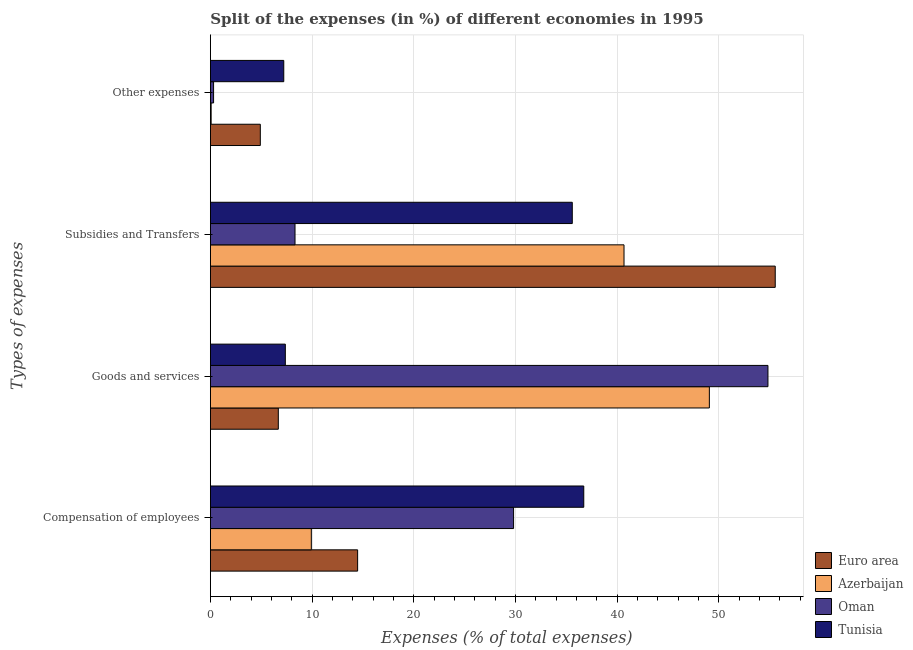How many groups of bars are there?
Your answer should be compact. 4. Are the number of bars per tick equal to the number of legend labels?
Offer a very short reply. Yes. What is the label of the 2nd group of bars from the top?
Keep it short and to the point. Subsidies and Transfers. What is the percentage of amount spent on compensation of employees in Oman?
Provide a short and direct response. 29.81. Across all countries, what is the maximum percentage of amount spent on subsidies?
Your response must be concise. 55.53. Across all countries, what is the minimum percentage of amount spent on goods and services?
Provide a short and direct response. 6.68. In which country was the percentage of amount spent on subsidies minimum?
Your answer should be very brief. Oman. What is the total percentage of amount spent on compensation of employees in the graph?
Provide a succinct answer. 90.92. What is the difference between the percentage of amount spent on goods and services in Azerbaijan and that in Oman?
Give a very brief answer. -5.76. What is the difference between the percentage of amount spent on compensation of employees in Azerbaijan and the percentage of amount spent on subsidies in Euro area?
Your response must be concise. -45.61. What is the average percentage of amount spent on subsidies per country?
Your answer should be very brief. 35.03. What is the difference between the percentage of amount spent on compensation of employees and percentage of amount spent on subsidies in Tunisia?
Your answer should be compact. 1.13. What is the ratio of the percentage of amount spent on goods and services in Euro area to that in Oman?
Offer a very short reply. 0.12. What is the difference between the highest and the second highest percentage of amount spent on subsidies?
Provide a short and direct response. 14.87. What is the difference between the highest and the lowest percentage of amount spent on other expenses?
Your answer should be compact. 7.14. Is the sum of the percentage of amount spent on goods and services in Euro area and Oman greater than the maximum percentage of amount spent on other expenses across all countries?
Your response must be concise. Yes. Is it the case that in every country, the sum of the percentage of amount spent on goods and services and percentage of amount spent on other expenses is greater than the sum of percentage of amount spent on subsidies and percentage of amount spent on compensation of employees?
Your response must be concise. No. What does the 4th bar from the top in Subsidies and Transfers represents?
Offer a terse response. Euro area. Is it the case that in every country, the sum of the percentage of amount spent on compensation of employees and percentage of amount spent on goods and services is greater than the percentage of amount spent on subsidies?
Offer a very short reply. No. Are all the bars in the graph horizontal?
Provide a short and direct response. Yes. What is the difference between two consecutive major ticks on the X-axis?
Provide a short and direct response. 10. Are the values on the major ticks of X-axis written in scientific E-notation?
Give a very brief answer. No. Does the graph contain any zero values?
Provide a succinct answer. No. What is the title of the graph?
Offer a terse response. Split of the expenses (in %) of different economies in 1995. Does "New Zealand" appear as one of the legend labels in the graph?
Give a very brief answer. No. What is the label or title of the X-axis?
Provide a short and direct response. Expenses (% of total expenses). What is the label or title of the Y-axis?
Your response must be concise. Types of expenses. What is the Expenses (% of total expenses) in Euro area in Compensation of employees?
Make the answer very short. 14.48. What is the Expenses (% of total expenses) in Azerbaijan in Compensation of employees?
Give a very brief answer. 9.92. What is the Expenses (% of total expenses) in Oman in Compensation of employees?
Your answer should be very brief. 29.81. What is the Expenses (% of total expenses) of Tunisia in Compensation of employees?
Keep it short and to the point. 36.71. What is the Expenses (% of total expenses) of Euro area in Goods and services?
Provide a succinct answer. 6.68. What is the Expenses (% of total expenses) in Azerbaijan in Goods and services?
Provide a short and direct response. 49.06. What is the Expenses (% of total expenses) in Oman in Goods and services?
Your answer should be very brief. 54.82. What is the Expenses (% of total expenses) in Tunisia in Goods and services?
Your response must be concise. 7.37. What is the Expenses (% of total expenses) in Euro area in Subsidies and Transfers?
Keep it short and to the point. 55.53. What is the Expenses (% of total expenses) of Azerbaijan in Subsidies and Transfers?
Ensure brevity in your answer.  40.67. What is the Expenses (% of total expenses) of Oman in Subsidies and Transfers?
Your response must be concise. 8.32. What is the Expenses (% of total expenses) in Tunisia in Subsidies and Transfers?
Provide a short and direct response. 35.58. What is the Expenses (% of total expenses) in Euro area in Other expenses?
Offer a terse response. 4.91. What is the Expenses (% of total expenses) in Azerbaijan in Other expenses?
Provide a succinct answer. 0.07. What is the Expenses (% of total expenses) in Oman in Other expenses?
Provide a short and direct response. 0.31. What is the Expenses (% of total expenses) in Tunisia in Other expenses?
Keep it short and to the point. 7.22. Across all Types of expenses, what is the maximum Expenses (% of total expenses) in Euro area?
Offer a very short reply. 55.53. Across all Types of expenses, what is the maximum Expenses (% of total expenses) of Azerbaijan?
Make the answer very short. 49.06. Across all Types of expenses, what is the maximum Expenses (% of total expenses) of Oman?
Ensure brevity in your answer.  54.82. Across all Types of expenses, what is the maximum Expenses (% of total expenses) in Tunisia?
Your answer should be compact. 36.71. Across all Types of expenses, what is the minimum Expenses (% of total expenses) of Euro area?
Ensure brevity in your answer.  4.91. Across all Types of expenses, what is the minimum Expenses (% of total expenses) in Azerbaijan?
Provide a short and direct response. 0.07. Across all Types of expenses, what is the minimum Expenses (% of total expenses) of Oman?
Give a very brief answer. 0.31. Across all Types of expenses, what is the minimum Expenses (% of total expenses) in Tunisia?
Offer a very short reply. 7.22. What is the total Expenses (% of total expenses) of Euro area in the graph?
Your response must be concise. 81.6. What is the total Expenses (% of total expenses) of Azerbaijan in the graph?
Make the answer very short. 99.72. What is the total Expenses (% of total expenses) of Oman in the graph?
Provide a short and direct response. 93.26. What is the total Expenses (% of total expenses) in Tunisia in the graph?
Offer a terse response. 86.87. What is the difference between the Expenses (% of total expenses) in Euro area in Compensation of employees and that in Goods and services?
Provide a succinct answer. 7.8. What is the difference between the Expenses (% of total expenses) in Azerbaijan in Compensation of employees and that in Goods and services?
Provide a short and direct response. -39.13. What is the difference between the Expenses (% of total expenses) in Oman in Compensation of employees and that in Goods and services?
Offer a terse response. -25.01. What is the difference between the Expenses (% of total expenses) of Tunisia in Compensation of employees and that in Goods and services?
Keep it short and to the point. 29.34. What is the difference between the Expenses (% of total expenses) in Euro area in Compensation of employees and that in Subsidies and Transfers?
Give a very brief answer. -41.06. What is the difference between the Expenses (% of total expenses) of Azerbaijan in Compensation of employees and that in Subsidies and Transfers?
Offer a terse response. -30.74. What is the difference between the Expenses (% of total expenses) in Oman in Compensation of employees and that in Subsidies and Transfers?
Your response must be concise. 21.49. What is the difference between the Expenses (% of total expenses) of Tunisia in Compensation of employees and that in Subsidies and Transfers?
Ensure brevity in your answer.  1.13. What is the difference between the Expenses (% of total expenses) in Euro area in Compensation of employees and that in Other expenses?
Provide a succinct answer. 9.57. What is the difference between the Expenses (% of total expenses) of Azerbaijan in Compensation of employees and that in Other expenses?
Ensure brevity in your answer.  9.85. What is the difference between the Expenses (% of total expenses) of Oman in Compensation of employees and that in Other expenses?
Offer a terse response. 29.49. What is the difference between the Expenses (% of total expenses) in Tunisia in Compensation of employees and that in Other expenses?
Your answer should be very brief. 29.5. What is the difference between the Expenses (% of total expenses) of Euro area in Goods and services and that in Subsidies and Transfers?
Provide a succinct answer. -48.86. What is the difference between the Expenses (% of total expenses) of Azerbaijan in Goods and services and that in Subsidies and Transfers?
Provide a succinct answer. 8.39. What is the difference between the Expenses (% of total expenses) in Oman in Goods and services and that in Subsidies and Transfers?
Your answer should be very brief. 46.5. What is the difference between the Expenses (% of total expenses) in Tunisia in Goods and services and that in Subsidies and Transfers?
Your response must be concise. -28.21. What is the difference between the Expenses (% of total expenses) in Euro area in Goods and services and that in Other expenses?
Offer a terse response. 1.77. What is the difference between the Expenses (% of total expenses) in Azerbaijan in Goods and services and that in Other expenses?
Provide a short and direct response. 48.98. What is the difference between the Expenses (% of total expenses) in Oman in Goods and services and that in Other expenses?
Ensure brevity in your answer.  54.5. What is the difference between the Expenses (% of total expenses) of Tunisia in Goods and services and that in Other expenses?
Your answer should be very brief. 0.15. What is the difference between the Expenses (% of total expenses) of Euro area in Subsidies and Transfers and that in Other expenses?
Ensure brevity in your answer.  50.63. What is the difference between the Expenses (% of total expenses) of Azerbaijan in Subsidies and Transfers and that in Other expenses?
Your answer should be very brief. 40.59. What is the difference between the Expenses (% of total expenses) of Oman in Subsidies and Transfers and that in Other expenses?
Offer a terse response. 8.01. What is the difference between the Expenses (% of total expenses) in Tunisia in Subsidies and Transfers and that in Other expenses?
Your answer should be compact. 28.36. What is the difference between the Expenses (% of total expenses) of Euro area in Compensation of employees and the Expenses (% of total expenses) of Azerbaijan in Goods and services?
Your answer should be very brief. -34.58. What is the difference between the Expenses (% of total expenses) of Euro area in Compensation of employees and the Expenses (% of total expenses) of Oman in Goods and services?
Keep it short and to the point. -40.34. What is the difference between the Expenses (% of total expenses) in Euro area in Compensation of employees and the Expenses (% of total expenses) in Tunisia in Goods and services?
Your response must be concise. 7.11. What is the difference between the Expenses (% of total expenses) of Azerbaijan in Compensation of employees and the Expenses (% of total expenses) of Oman in Goods and services?
Give a very brief answer. -44.89. What is the difference between the Expenses (% of total expenses) in Azerbaijan in Compensation of employees and the Expenses (% of total expenses) in Tunisia in Goods and services?
Ensure brevity in your answer.  2.56. What is the difference between the Expenses (% of total expenses) in Oman in Compensation of employees and the Expenses (% of total expenses) in Tunisia in Goods and services?
Keep it short and to the point. 22.44. What is the difference between the Expenses (% of total expenses) in Euro area in Compensation of employees and the Expenses (% of total expenses) in Azerbaijan in Subsidies and Transfers?
Keep it short and to the point. -26.19. What is the difference between the Expenses (% of total expenses) in Euro area in Compensation of employees and the Expenses (% of total expenses) in Oman in Subsidies and Transfers?
Your answer should be very brief. 6.15. What is the difference between the Expenses (% of total expenses) in Euro area in Compensation of employees and the Expenses (% of total expenses) in Tunisia in Subsidies and Transfers?
Offer a terse response. -21.1. What is the difference between the Expenses (% of total expenses) in Azerbaijan in Compensation of employees and the Expenses (% of total expenses) in Oman in Subsidies and Transfers?
Make the answer very short. 1.6. What is the difference between the Expenses (% of total expenses) of Azerbaijan in Compensation of employees and the Expenses (% of total expenses) of Tunisia in Subsidies and Transfers?
Your answer should be compact. -25.66. What is the difference between the Expenses (% of total expenses) in Oman in Compensation of employees and the Expenses (% of total expenses) in Tunisia in Subsidies and Transfers?
Make the answer very short. -5.77. What is the difference between the Expenses (% of total expenses) in Euro area in Compensation of employees and the Expenses (% of total expenses) in Azerbaijan in Other expenses?
Your response must be concise. 14.4. What is the difference between the Expenses (% of total expenses) of Euro area in Compensation of employees and the Expenses (% of total expenses) of Oman in Other expenses?
Offer a terse response. 14.16. What is the difference between the Expenses (% of total expenses) of Euro area in Compensation of employees and the Expenses (% of total expenses) of Tunisia in Other expenses?
Your answer should be very brief. 7.26. What is the difference between the Expenses (% of total expenses) of Azerbaijan in Compensation of employees and the Expenses (% of total expenses) of Oman in Other expenses?
Ensure brevity in your answer.  9.61. What is the difference between the Expenses (% of total expenses) in Azerbaijan in Compensation of employees and the Expenses (% of total expenses) in Tunisia in Other expenses?
Make the answer very short. 2.71. What is the difference between the Expenses (% of total expenses) in Oman in Compensation of employees and the Expenses (% of total expenses) in Tunisia in Other expenses?
Make the answer very short. 22.59. What is the difference between the Expenses (% of total expenses) of Euro area in Goods and services and the Expenses (% of total expenses) of Azerbaijan in Subsidies and Transfers?
Offer a very short reply. -33.99. What is the difference between the Expenses (% of total expenses) in Euro area in Goods and services and the Expenses (% of total expenses) in Oman in Subsidies and Transfers?
Give a very brief answer. -1.64. What is the difference between the Expenses (% of total expenses) in Euro area in Goods and services and the Expenses (% of total expenses) in Tunisia in Subsidies and Transfers?
Offer a very short reply. -28.9. What is the difference between the Expenses (% of total expenses) in Azerbaijan in Goods and services and the Expenses (% of total expenses) in Oman in Subsidies and Transfers?
Your answer should be very brief. 40.74. What is the difference between the Expenses (% of total expenses) of Azerbaijan in Goods and services and the Expenses (% of total expenses) of Tunisia in Subsidies and Transfers?
Provide a short and direct response. 13.48. What is the difference between the Expenses (% of total expenses) in Oman in Goods and services and the Expenses (% of total expenses) in Tunisia in Subsidies and Transfers?
Give a very brief answer. 19.24. What is the difference between the Expenses (% of total expenses) of Euro area in Goods and services and the Expenses (% of total expenses) of Azerbaijan in Other expenses?
Give a very brief answer. 6.6. What is the difference between the Expenses (% of total expenses) of Euro area in Goods and services and the Expenses (% of total expenses) of Oman in Other expenses?
Your answer should be compact. 6.36. What is the difference between the Expenses (% of total expenses) in Euro area in Goods and services and the Expenses (% of total expenses) in Tunisia in Other expenses?
Give a very brief answer. -0.54. What is the difference between the Expenses (% of total expenses) of Azerbaijan in Goods and services and the Expenses (% of total expenses) of Oman in Other expenses?
Keep it short and to the point. 48.74. What is the difference between the Expenses (% of total expenses) of Azerbaijan in Goods and services and the Expenses (% of total expenses) of Tunisia in Other expenses?
Give a very brief answer. 41.84. What is the difference between the Expenses (% of total expenses) in Oman in Goods and services and the Expenses (% of total expenses) in Tunisia in Other expenses?
Offer a very short reply. 47.6. What is the difference between the Expenses (% of total expenses) of Euro area in Subsidies and Transfers and the Expenses (% of total expenses) of Azerbaijan in Other expenses?
Your answer should be very brief. 55.46. What is the difference between the Expenses (% of total expenses) of Euro area in Subsidies and Transfers and the Expenses (% of total expenses) of Oman in Other expenses?
Your answer should be very brief. 55.22. What is the difference between the Expenses (% of total expenses) of Euro area in Subsidies and Transfers and the Expenses (% of total expenses) of Tunisia in Other expenses?
Give a very brief answer. 48.32. What is the difference between the Expenses (% of total expenses) in Azerbaijan in Subsidies and Transfers and the Expenses (% of total expenses) in Oman in Other expenses?
Ensure brevity in your answer.  40.35. What is the difference between the Expenses (% of total expenses) in Azerbaijan in Subsidies and Transfers and the Expenses (% of total expenses) in Tunisia in Other expenses?
Your answer should be compact. 33.45. What is the difference between the Expenses (% of total expenses) of Oman in Subsidies and Transfers and the Expenses (% of total expenses) of Tunisia in Other expenses?
Provide a short and direct response. 1.11. What is the average Expenses (% of total expenses) in Euro area per Types of expenses?
Provide a succinct answer. 20.4. What is the average Expenses (% of total expenses) in Azerbaijan per Types of expenses?
Keep it short and to the point. 24.93. What is the average Expenses (% of total expenses) in Oman per Types of expenses?
Offer a terse response. 23.32. What is the average Expenses (% of total expenses) of Tunisia per Types of expenses?
Keep it short and to the point. 21.72. What is the difference between the Expenses (% of total expenses) of Euro area and Expenses (% of total expenses) of Azerbaijan in Compensation of employees?
Your answer should be compact. 4.55. What is the difference between the Expenses (% of total expenses) in Euro area and Expenses (% of total expenses) in Oman in Compensation of employees?
Your answer should be compact. -15.33. What is the difference between the Expenses (% of total expenses) in Euro area and Expenses (% of total expenses) in Tunisia in Compensation of employees?
Give a very brief answer. -22.23. What is the difference between the Expenses (% of total expenses) in Azerbaijan and Expenses (% of total expenses) in Oman in Compensation of employees?
Ensure brevity in your answer.  -19.88. What is the difference between the Expenses (% of total expenses) in Azerbaijan and Expenses (% of total expenses) in Tunisia in Compensation of employees?
Keep it short and to the point. -26.79. What is the difference between the Expenses (% of total expenses) of Oman and Expenses (% of total expenses) of Tunisia in Compensation of employees?
Provide a short and direct response. -6.9. What is the difference between the Expenses (% of total expenses) in Euro area and Expenses (% of total expenses) in Azerbaijan in Goods and services?
Offer a very short reply. -42.38. What is the difference between the Expenses (% of total expenses) of Euro area and Expenses (% of total expenses) of Oman in Goods and services?
Offer a terse response. -48.14. What is the difference between the Expenses (% of total expenses) in Euro area and Expenses (% of total expenses) in Tunisia in Goods and services?
Your answer should be very brief. -0.69. What is the difference between the Expenses (% of total expenses) of Azerbaijan and Expenses (% of total expenses) of Oman in Goods and services?
Your answer should be compact. -5.76. What is the difference between the Expenses (% of total expenses) in Azerbaijan and Expenses (% of total expenses) in Tunisia in Goods and services?
Keep it short and to the point. 41.69. What is the difference between the Expenses (% of total expenses) in Oman and Expenses (% of total expenses) in Tunisia in Goods and services?
Ensure brevity in your answer.  47.45. What is the difference between the Expenses (% of total expenses) in Euro area and Expenses (% of total expenses) in Azerbaijan in Subsidies and Transfers?
Offer a very short reply. 14.87. What is the difference between the Expenses (% of total expenses) in Euro area and Expenses (% of total expenses) in Oman in Subsidies and Transfers?
Give a very brief answer. 47.21. What is the difference between the Expenses (% of total expenses) of Euro area and Expenses (% of total expenses) of Tunisia in Subsidies and Transfers?
Your response must be concise. 19.95. What is the difference between the Expenses (% of total expenses) of Azerbaijan and Expenses (% of total expenses) of Oman in Subsidies and Transfers?
Give a very brief answer. 32.35. What is the difference between the Expenses (% of total expenses) in Azerbaijan and Expenses (% of total expenses) in Tunisia in Subsidies and Transfers?
Your answer should be very brief. 5.09. What is the difference between the Expenses (% of total expenses) in Oman and Expenses (% of total expenses) in Tunisia in Subsidies and Transfers?
Your answer should be very brief. -27.26. What is the difference between the Expenses (% of total expenses) of Euro area and Expenses (% of total expenses) of Azerbaijan in Other expenses?
Keep it short and to the point. 4.83. What is the difference between the Expenses (% of total expenses) in Euro area and Expenses (% of total expenses) in Oman in Other expenses?
Your response must be concise. 4.59. What is the difference between the Expenses (% of total expenses) in Euro area and Expenses (% of total expenses) in Tunisia in Other expenses?
Your answer should be very brief. -2.31. What is the difference between the Expenses (% of total expenses) in Azerbaijan and Expenses (% of total expenses) in Oman in Other expenses?
Keep it short and to the point. -0.24. What is the difference between the Expenses (% of total expenses) in Azerbaijan and Expenses (% of total expenses) in Tunisia in Other expenses?
Provide a succinct answer. -7.14. What is the difference between the Expenses (% of total expenses) of Oman and Expenses (% of total expenses) of Tunisia in Other expenses?
Make the answer very short. -6.9. What is the ratio of the Expenses (% of total expenses) of Euro area in Compensation of employees to that in Goods and services?
Your answer should be very brief. 2.17. What is the ratio of the Expenses (% of total expenses) in Azerbaijan in Compensation of employees to that in Goods and services?
Keep it short and to the point. 0.2. What is the ratio of the Expenses (% of total expenses) in Oman in Compensation of employees to that in Goods and services?
Make the answer very short. 0.54. What is the ratio of the Expenses (% of total expenses) in Tunisia in Compensation of employees to that in Goods and services?
Offer a very short reply. 4.98. What is the ratio of the Expenses (% of total expenses) in Euro area in Compensation of employees to that in Subsidies and Transfers?
Your response must be concise. 0.26. What is the ratio of the Expenses (% of total expenses) in Azerbaijan in Compensation of employees to that in Subsidies and Transfers?
Your answer should be very brief. 0.24. What is the ratio of the Expenses (% of total expenses) of Oman in Compensation of employees to that in Subsidies and Transfers?
Keep it short and to the point. 3.58. What is the ratio of the Expenses (% of total expenses) of Tunisia in Compensation of employees to that in Subsidies and Transfers?
Make the answer very short. 1.03. What is the ratio of the Expenses (% of total expenses) in Euro area in Compensation of employees to that in Other expenses?
Keep it short and to the point. 2.95. What is the ratio of the Expenses (% of total expenses) of Azerbaijan in Compensation of employees to that in Other expenses?
Ensure brevity in your answer.  133.54. What is the ratio of the Expenses (% of total expenses) of Oman in Compensation of employees to that in Other expenses?
Your answer should be very brief. 94.8. What is the ratio of the Expenses (% of total expenses) of Tunisia in Compensation of employees to that in Other expenses?
Make the answer very short. 5.09. What is the ratio of the Expenses (% of total expenses) of Euro area in Goods and services to that in Subsidies and Transfers?
Offer a terse response. 0.12. What is the ratio of the Expenses (% of total expenses) of Azerbaijan in Goods and services to that in Subsidies and Transfers?
Your answer should be very brief. 1.21. What is the ratio of the Expenses (% of total expenses) in Oman in Goods and services to that in Subsidies and Transfers?
Offer a very short reply. 6.59. What is the ratio of the Expenses (% of total expenses) in Tunisia in Goods and services to that in Subsidies and Transfers?
Offer a terse response. 0.21. What is the ratio of the Expenses (% of total expenses) in Euro area in Goods and services to that in Other expenses?
Your answer should be compact. 1.36. What is the ratio of the Expenses (% of total expenses) of Azerbaijan in Goods and services to that in Other expenses?
Provide a succinct answer. 660.14. What is the ratio of the Expenses (% of total expenses) in Oman in Goods and services to that in Other expenses?
Ensure brevity in your answer.  174.33. What is the ratio of the Expenses (% of total expenses) in Tunisia in Goods and services to that in Other expenses?
Make the answer very short. 1.02. What is the ratio of the Expenses (% of total expenses) of Euro area in Subsidies and Transfers to that in Other expenses?
Ensure brevity in your answer.  11.31. What is the ratio of the Expenses (% of total expenses) in Azerbaijan in Subsidies and Transfers to that in Other expenses?
Your answer should be very brief. 547.23. What is the ratio of the Expenses (% of total expenses) of Oman in Subsidies and Transfers to that in Other expenses?
Provide a succinct answer. 26.46. What is the ratio of the Expenses (% of total expenses) of Tunisia in Subsidies and Transfers to that in Other expenses?
Your answer should be very brief. 4.93. What is the difference between the highest and the second highest Expenses (% of total expenses) of Euro area?
Your answer should be very brief. 41.06. What is the difference between the highest and the second highest Expenses (% of total expenses) of Azerbaijan?
Give a very brief answer. 8.39. What is the difference between the highest and the second highest Expenses (% of total expenses) in Oman?
Offer a terse response. 25.01. What is the difference between the highest and the second highest Expenses (% of total expenses) of Tunisia?
Your answer should be compact. 1.13. What is the difference between the highest and the lowest Expenses (% of total expenses) of Euro area?
Keep it short and to the point. 50.63. What is the difference between the highest and the lowest Expenses (% of total expenses) in Azerbaijan?
Your response must be concise. 48.98. What is the difference between the highest and the lowest Expenses (% of total expenses) of Oman?
Keep it short and to the point. 54.5. What is the difference between the highest and the lowest Expenses (% of total expenses) of Tunisia?
Give a very brief answer. 29.5. 